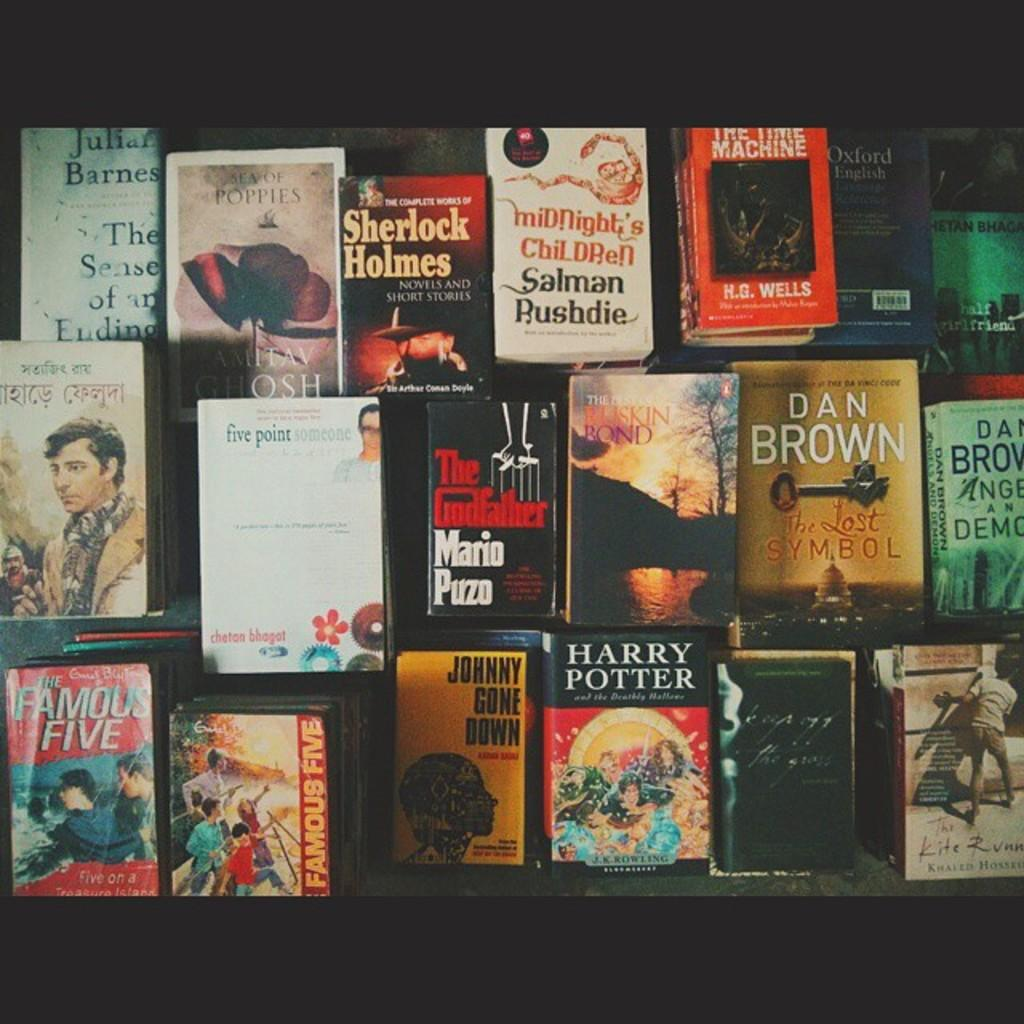Provide a one-sentence caption for the provided image. Several books near each other including The Godfather. 